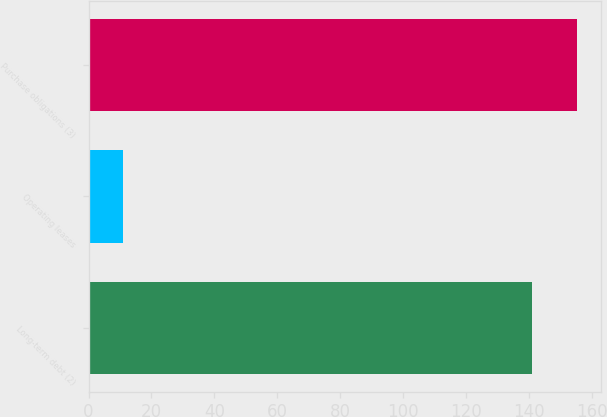Convert chart to OTSL. <chart><loc_0><loc_0><loc_500><loc_500><bar_chart><fcel>Long-term debt (2)<fcel>Operating leases<fcel>Purchase obligations (3)<nl><fcel>141<fcel>11<fcel>155.3<nl></chart> 